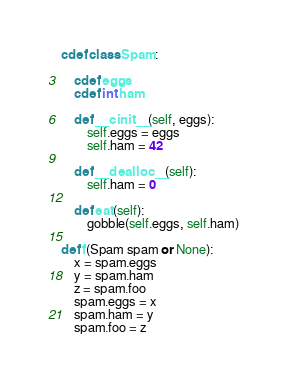<code> <loc_0><loc_0><loc_500><loc_500><_Cython_>cdef class Spam:

	cdef eggs
	cdef int ham

	def __cinit__(self, eggs):
		self.eggs = eggs
		self.ham = 42
	
	def __dealloc__(self):
		self.ham = 0
	
	def eat(self):
		gobble(self.eggs, self.ham)

def f(Spam spam or None):
	x = spam.eggs
	y = spam.ham
	z = spam.foo
	spam.eggs = x
	spam.ham = y
	spam.foo = z
</code> 